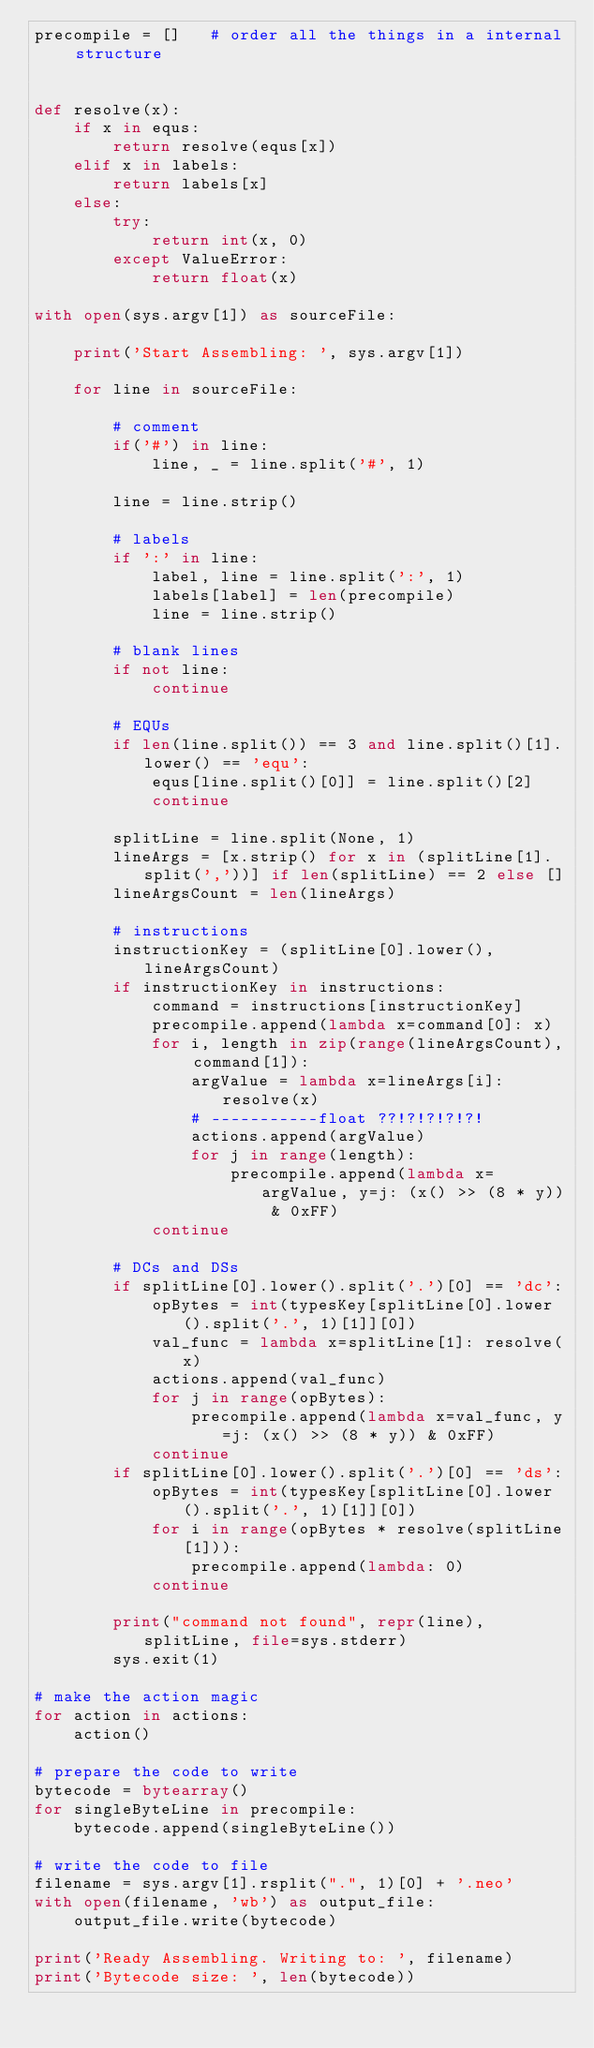<code> <loc_0><loc_0><loc_500><loc_500><_Python_>precompile = []   # order all the things in a internal structure


def resolve(x):
    if x in equs:
        return resolve(equs[x])
    elif x in labels:
        return labels[x]
    else:
        try:
            return int(x, 0)
        except ValueError:
            return float(x)

with open(sys.argv[1]) as sourceFile:

    print('Start Assembling: ', sys.argv[1])

    for line in sourceFile:

        # comment
        if('#') in line:
            line, _ = line.split('#', 1)

        line = line.strip()

        # labels
        if ':' in line:
            label, line = line.split(':', 1)
            labels[label] = len(precompile)
            line = line.strip()

        # blank lines
        if not line:
            continue

        # EQUs
        if len(line.split()) == 3 and line.split()[1].lower() == 'equ':
            equs[line.split()[0]] = line.split()[2]
            continue

        splitLine = line.split(None, 1)
        lineArgs = [x.strip() for x in (splitLine[1].split(','))] if len(splitLine) == 2 else []
        lineArgsCount = len(lineArgs)

        # instructions
        instructionKey = (splitLine[0].lower(), lineArgsCount)
        if instructionKey in instructions:
            command = instructions[instructionKey]
            precompile.append(lambda x=command[0]: x)
            for i, length in zip(range(lineArgsCount), command[1]):
                argValue = lambda x=lineArgs[i]: resolve(x)
                # -----------float ??!?!?!?!?!
                actions.append(argValue)
                for j in range(length):
                    precompile.append(lambda x=argValue, y=j: (x() >> (8 * y)) & 0xFF)
            continue

        # DCs and DSs
        if splitLine[0].lower().split('.')[0] == 'dc':
            opBytes = int(typesKey[splitLine[0].lower().split('.', 1)[1]][0])
            val_func = lambda x=splitLine[1]: resolve(x)
            actions.append(val_func)
            for j in range(opBytes):
                precompile.append(lambda x=val_func, y=j: (x() >> (8 * y)) & 0xFF)
            continue
        if splitLine[0].lower().split('.')[0] == 'ds':
            opBytes = int(typesKey[splitLine[0].lower().split('.', 1)[1]][0])
            for i in range(opBytes * resolve(splitLine[1])):
                precompile.append(lambda: 0)
            continue

        print("command not found", repr(line), splitLine, file=sys.stderr)
        sys.exit(1)

# make the action magic
for action in actions:
    action()

# prepare the code to write
bytecode = bytearray()
for singleByteLine in precompile:
    bytecode.append(singleByteLine())

# write the code to file
filename = sys.argv[1].rsplit(".", 1)[0] + '.neo'
with open(filename, 'wb') as output_file:
    output_file.write(bytecode)

print('Ready Assembling. Writing to: ', filename)
print('Bytecode size: ', len(bytecode))
</code> 